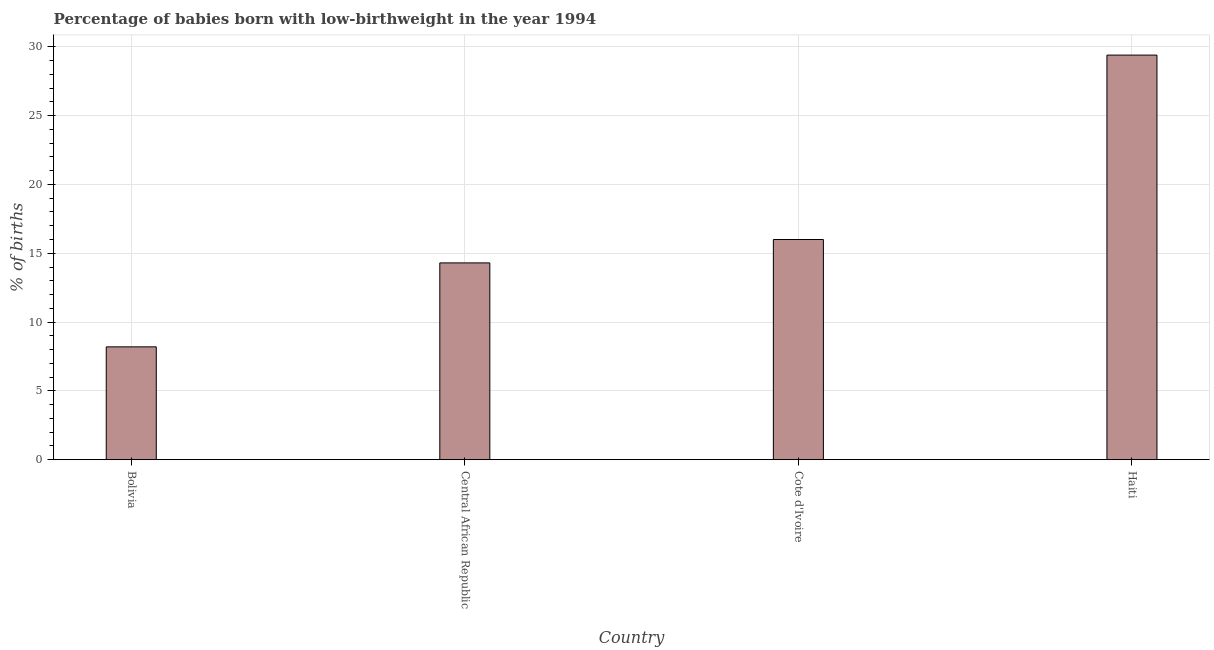Does the graph contain any zero values?
Provide a short and direct response. No. What is the title of the graph?
Offer a terse response. Percentage of babies born with low-birthweight in the year 1994. What is the label or title of the X-axis?
Give a very brief answer. Country. What is the label or title of the Y-axis?
Ensure brevity in your answer.  % of births. Across all countries, what is the maximum percentage of babies who were born with low-birthweight?
Offer a terse response. 29.4. In which country was the percentage of babies who were born with low-birthweight maximum?
Keep it short and to the point. Haiti. In which country was the percentage of babies who were born with low-birthweight minimum?
Offer a terse response. Bolivia. What is the sum of the percentage of babies who were born with low-birthweight?
Your answer should be compact. 67.9. What is the average percentage of babies who were born with low-birthweight per country?
Provide a succinct answer. 16.98. What is the median percentage of babies who were born with low-birthweight?
Offer a very short reply. 15.15. What is the ratio of the percentage of babies who were born with low-birthweight in Central African Republic to that in Cote d'Ivoire?
Your answer should be compact. 0.89. Is the percentage of babies who were born with low-birthweight in Cote d'Ivoire less than that in Haiti?
Your answer should be compact. Yes. Is the difference between the percentage of babies who were born with low-birthweight in Cote d'Ivoire and Haiti greater than the difference between any two countries?
Give a very brief answer. No. What is the difference between the highest and the second highest percentage of babies who were born with low-birthweight?
Provide a short and direct response. 13.4. What is the difference between the highest and the lowest percentage of babies who were born with low-birthweight?
Offer a terse response. 21.2. In how many countries, is the percentage of babies who were born with low-birthweight greater than the average percentage of babies who were born with low-birthweight taken over all countries?
Provide a succinct answer. 1. How many bars are there?
Offer a terse response. 4. Are the values on the major ticks of Y-axis written in scientific E-notation?
Make the answer very short. No. What is the % of births of Central African Republic?
Offer a very short reply. 14.3. What is the % of births in Haiti?
Offer a terse response. 29.4. What is the difference between the % of births in Bolivia and Cote d'Ivoire?
Offer a terse response. -7.8. What is the difference between the % of births in Bolivia and Haiti?
Make the answer very short. -21.2. What is the difference between the % of births in Central African Republic and Cote d'Ivoire?
Your answer should be compact. -1.7. What is the difference between the % of births in Central African Republic and Haiti?
Provide a succinct answer. -15.1. What is the ratio of the % of births in Bolivia to that in Central African Republic?
Provide a short and direct response. 0.57. What is the ratio of the % of births in Bolivia to that in Cote d'Ivoire?
Provide a succinct answer. 0.51. What is the ratio of the % of births in Bolivia to that in Haiti?
Your response must be concise. 0.28. What is the ratio of the % of births in Central African Republic to that in Cote d'Ivoire?
Your answer should be very brief. 0.89. What is the ratio of the % of births in Central African Republic to that in Haiti?
Keep it short and to the point. 0.49. What is the ratio of the % of births in Cote d'Ivoire to that in Haiti?
Give a very brief answer. 0.54. 